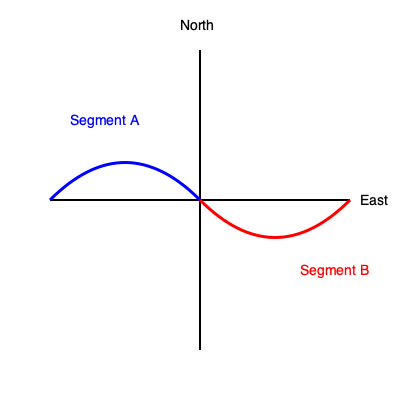As part of a new pipeline project, you need to connect two curved pipeline segments (A and B) to create the most efficient route. Segment A starts from the West and curves towards the Northeast, while Segment B starts from the East and curves towards the Southwest. How many degrees should Segment B be rotated clockwise to create a smooth, continuous pipeline with minimal curvature? To solve this problem, we need to analyze the curvature of both segments and determine the optimal rotation for Segment B. Let's approach this step-by-step:

1. Observe that Segment A curves 90° from West to North.
2. Segment B, in its current position, curves 90° from East to South.
3. To create a smooth, continuous pipeline, we want the end of Segment A to align with the beginning of Segment B.
4. If we rotate Segment B 180° clockwise:
   - Its starting point will now be in the West, aligning with the end of Segment A.
   - Its curvature will now be from West to North, matching Segment A's curvature.
5. This rotation creates a symmetrical S-shaped pipeline with minimal overall curvature.
6. Any rotation less or more than 180° would result in a sharper curve or discontinuity at the connection point.

Therefore, rotating Segment B by 180° clockwise will create the most efficient and smooth pipeline route.
Answer: 180° 